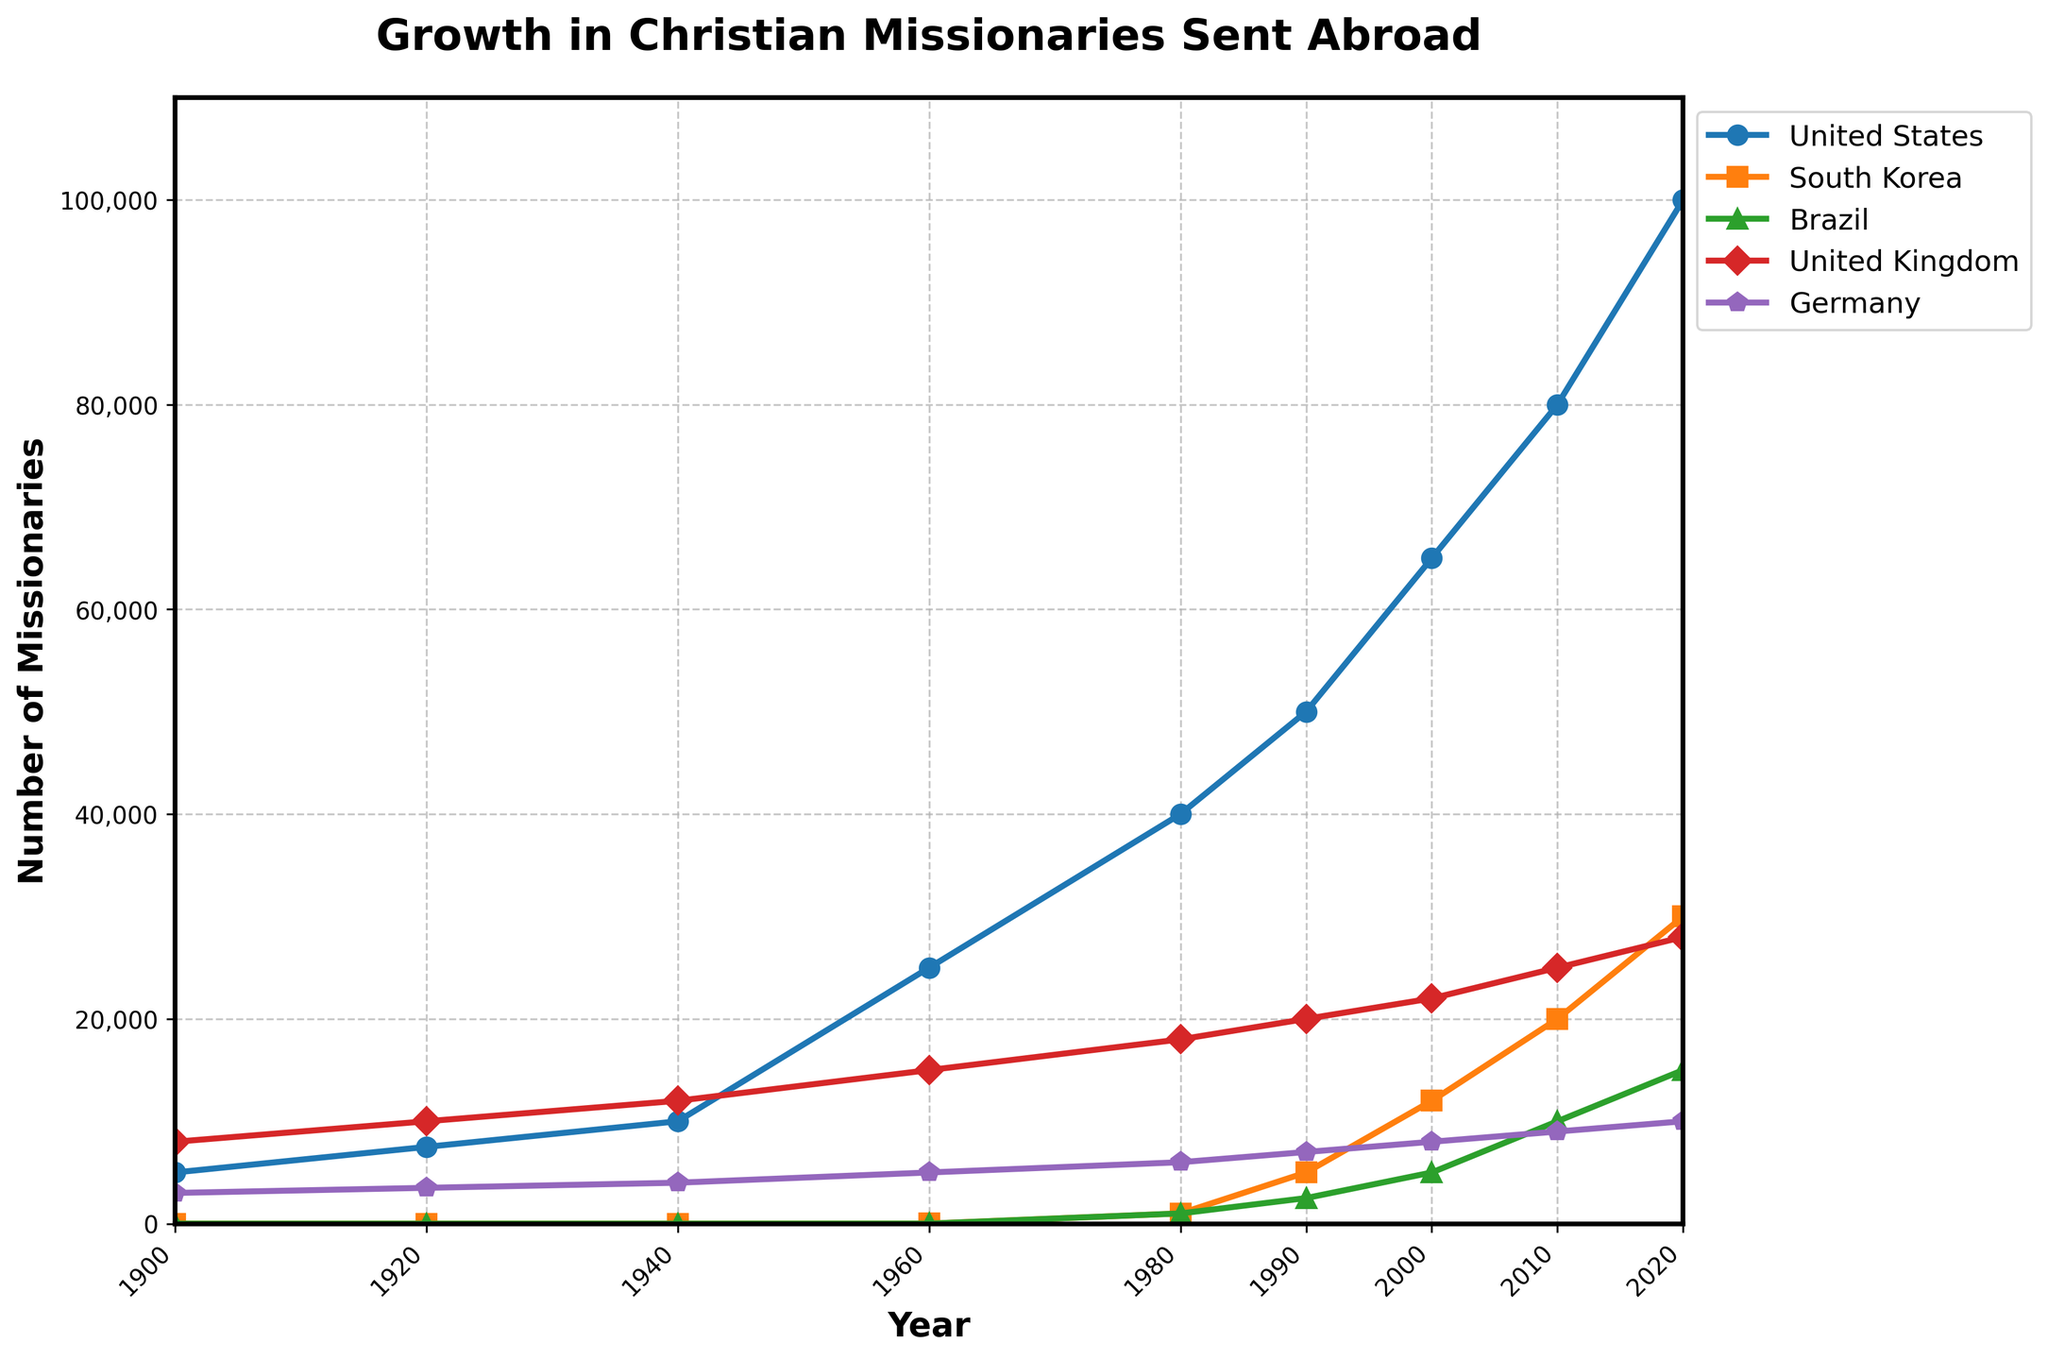Which country had the highest number of missionaries in 1900? The line chart shows the data point for each country in 1900, where the United Kingdom has the highest number at 8,000 missionaries.
Answer: United Kingdom Between 1980 and 2000, which country had the most significant increase in the number of missionaries sent abroad? By comparing the slopes of the lines for each country between 1980 and 2000, the United States had the most significant increase from 40,000 to 65,000, a 25,000 increase.
Answer: United States What is the total number of missionaries sent abroad by Brazil and South Korea in 2020? In 2020, Brazil sent 15,000 missionaries and South Korea sent 30,000. Summing these two values gives 15,000 + 30,000.
Answer: 45,000 In which year did Germany have 5,000 missionaries sent abroad? The line for Germany reaches the 5,000 mark in the year 1960, as indicated by the intersection of the line and the y-axis value of 5,000.
Answer: 1960 How does the number of missionaries sent by the United Kingdom in 1920 compare to that in 2020? In 1920, the United Kingdom sent 10,000 missionaries while in 2020 it sent 28,000 missionaries. Hence, 28,000 is greater than 10,000.
Answer: Greater in 2020 Which country showed the smallest number of missionaries sent in 1980? In 1980, the chart shows the smallest data points in South Korea and Brazil, both sending 1,000 missionaries each.
Answer: South Korea and Brazil Between 1900 and 1960, which country saw a decline in the number of missionaries sent abroad? Analyzing the lines between these years shows that no country's number of missionaries declined.
Answer: None By how much did the number of missionaries sent by South Korea increase between 1990 and 2010? South Korea sent 5,000 missionaries in 1990 and 20,000 in 2010. Thus, the increase is 20,000 - 5,000.
Answer: 15,000 What was the total number of missionaries sent by all listed countries in 1940? Adding up the 1940 values for each country: USA (10,000), South Korea (0), Brazil (0), UK (12,000), Germany (4,000) gives 10,000 + 0 + 0 + 12,000 + 4,000.
Answer: 26,000 How did the number of missionaries sent by Brazil change between 2000 and 2020? Observing Brazil's line, it rises from 5,000 in 2000 to 15,000 in 2020, an increase of 10,000.
Answer: Increased by 10,000 